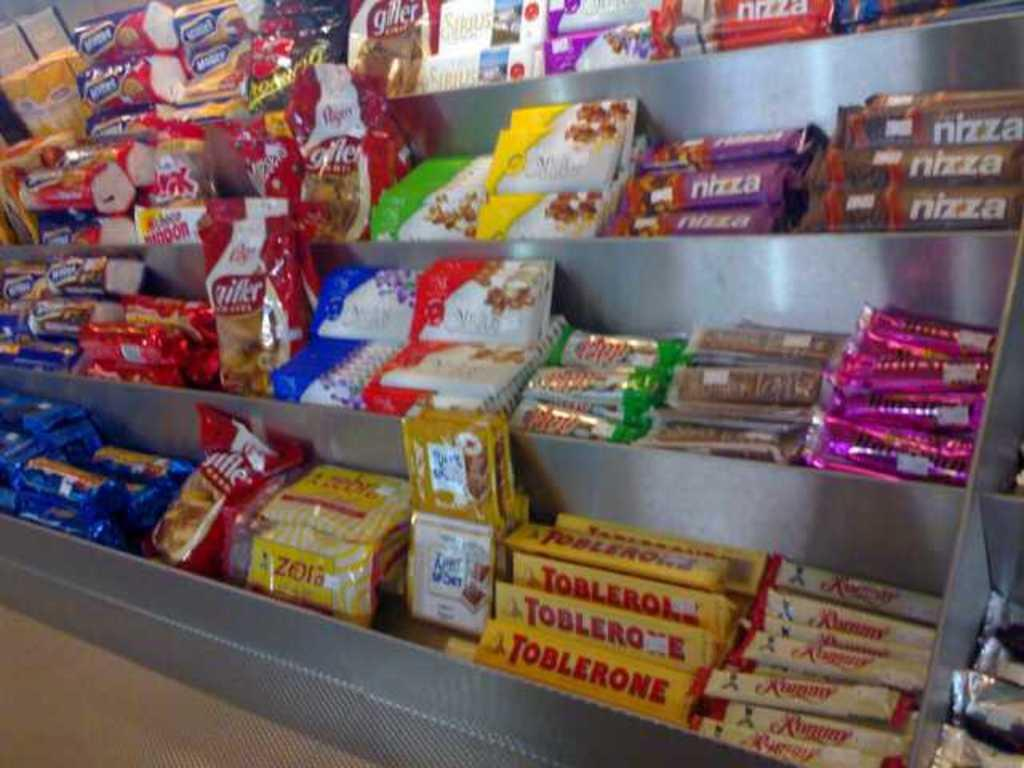<image>
Share a concise interpretation of the image provided. a candy aisle display with goods like Nizza 